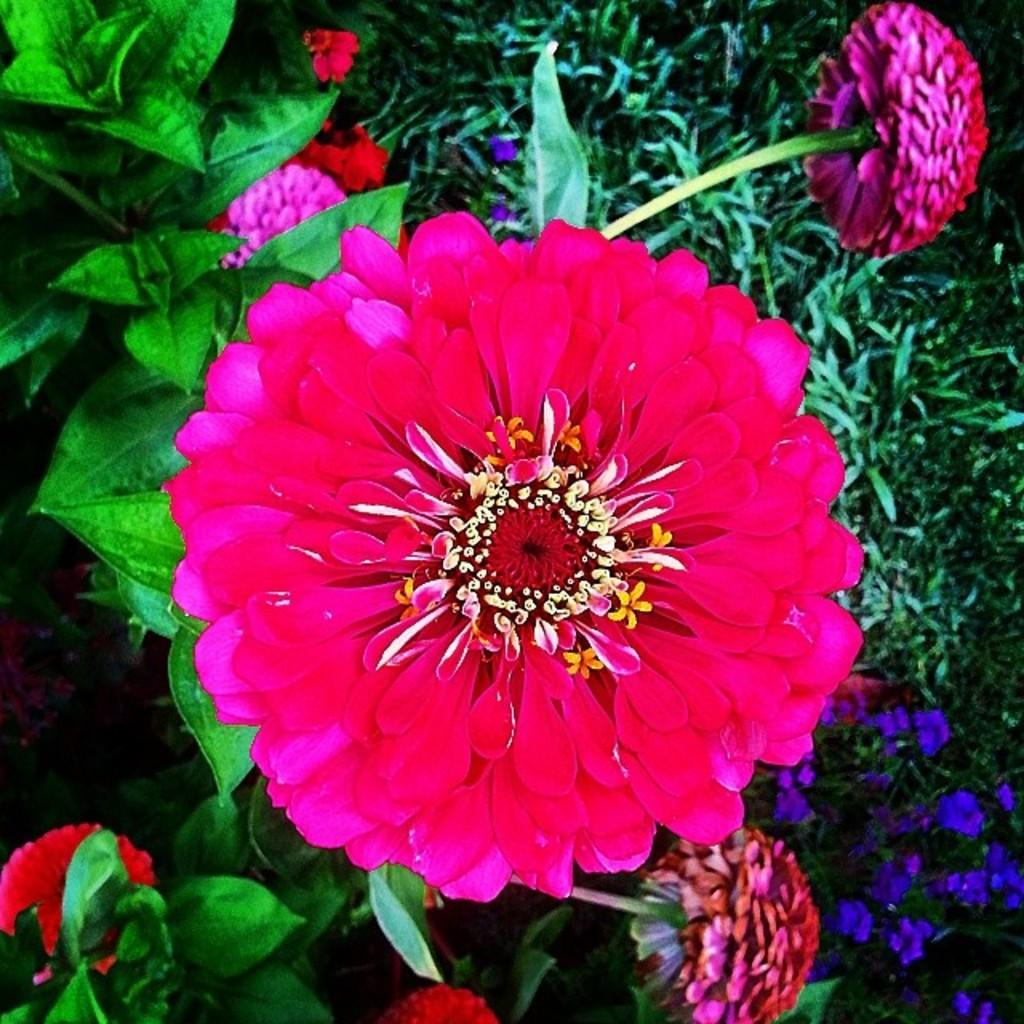What type of plants can be seen in the image? There are flowers in the image. What color are the flowers? The flowers are pink in color. What else can be seen in the image besides the flowers? There are leaves in the image. What color are the leaves? The leaves are green in color. What type of seat can be seen in the image? There is no seat present in the image; it features flowers and leaves. What role does the plough play in the image? There is no plough present in the image; it only contains flowers and leaves. 